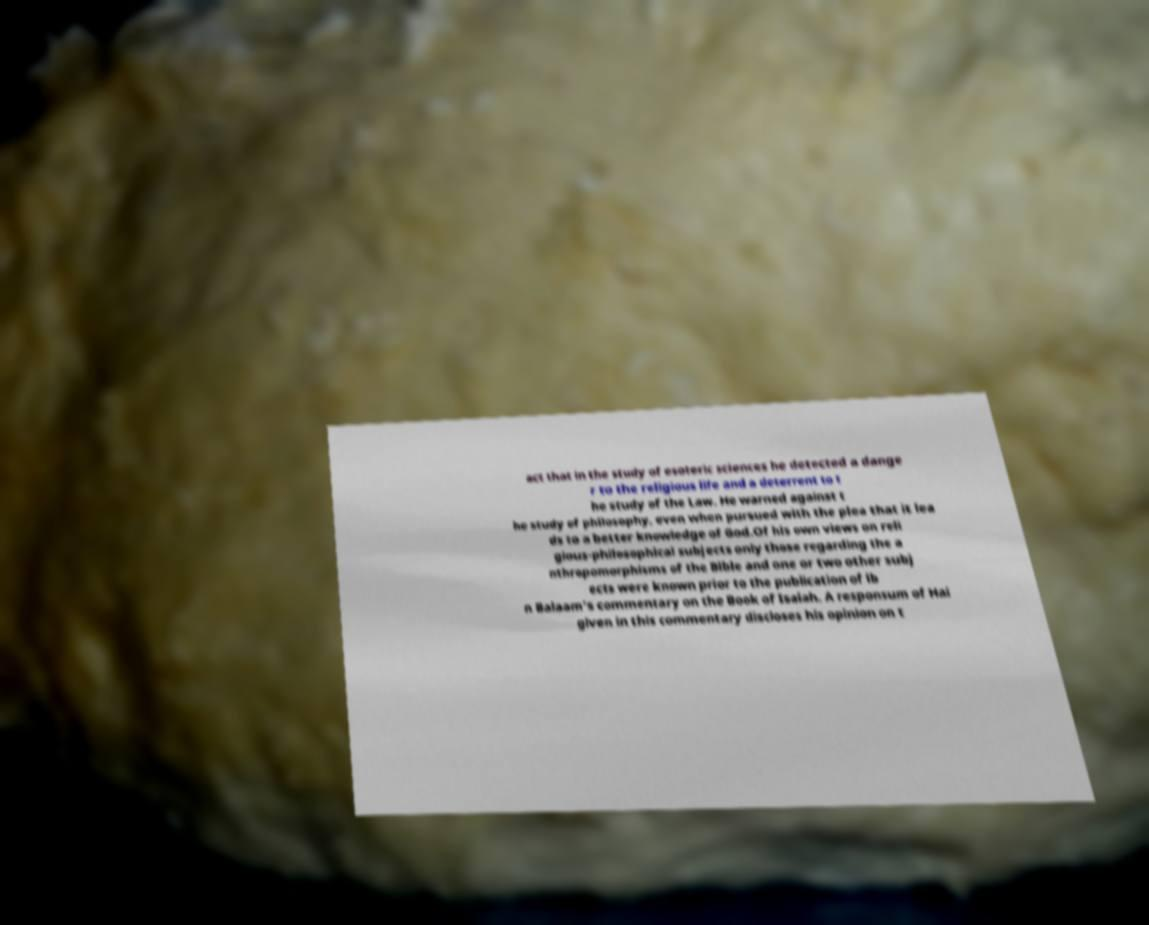Please read and relay the text visible in this image. What does it say? act that in the study of esoteric sciences he detected a dange r to the religious life and a deterrent to t he study of the Law. He warned against t he study of philosophy, even when pursued with the plea that it lea ds to a better knowledge of God.Of his own views on reli gious-philosophical subjects only those regarding the a nthropomorphisms of the Bible and one or two other subj ects were known prior to the publication of ib n Balaam's commentary on the Book of Isaiah. A responsum of Hai given in this commentary discloses his opinion on t 